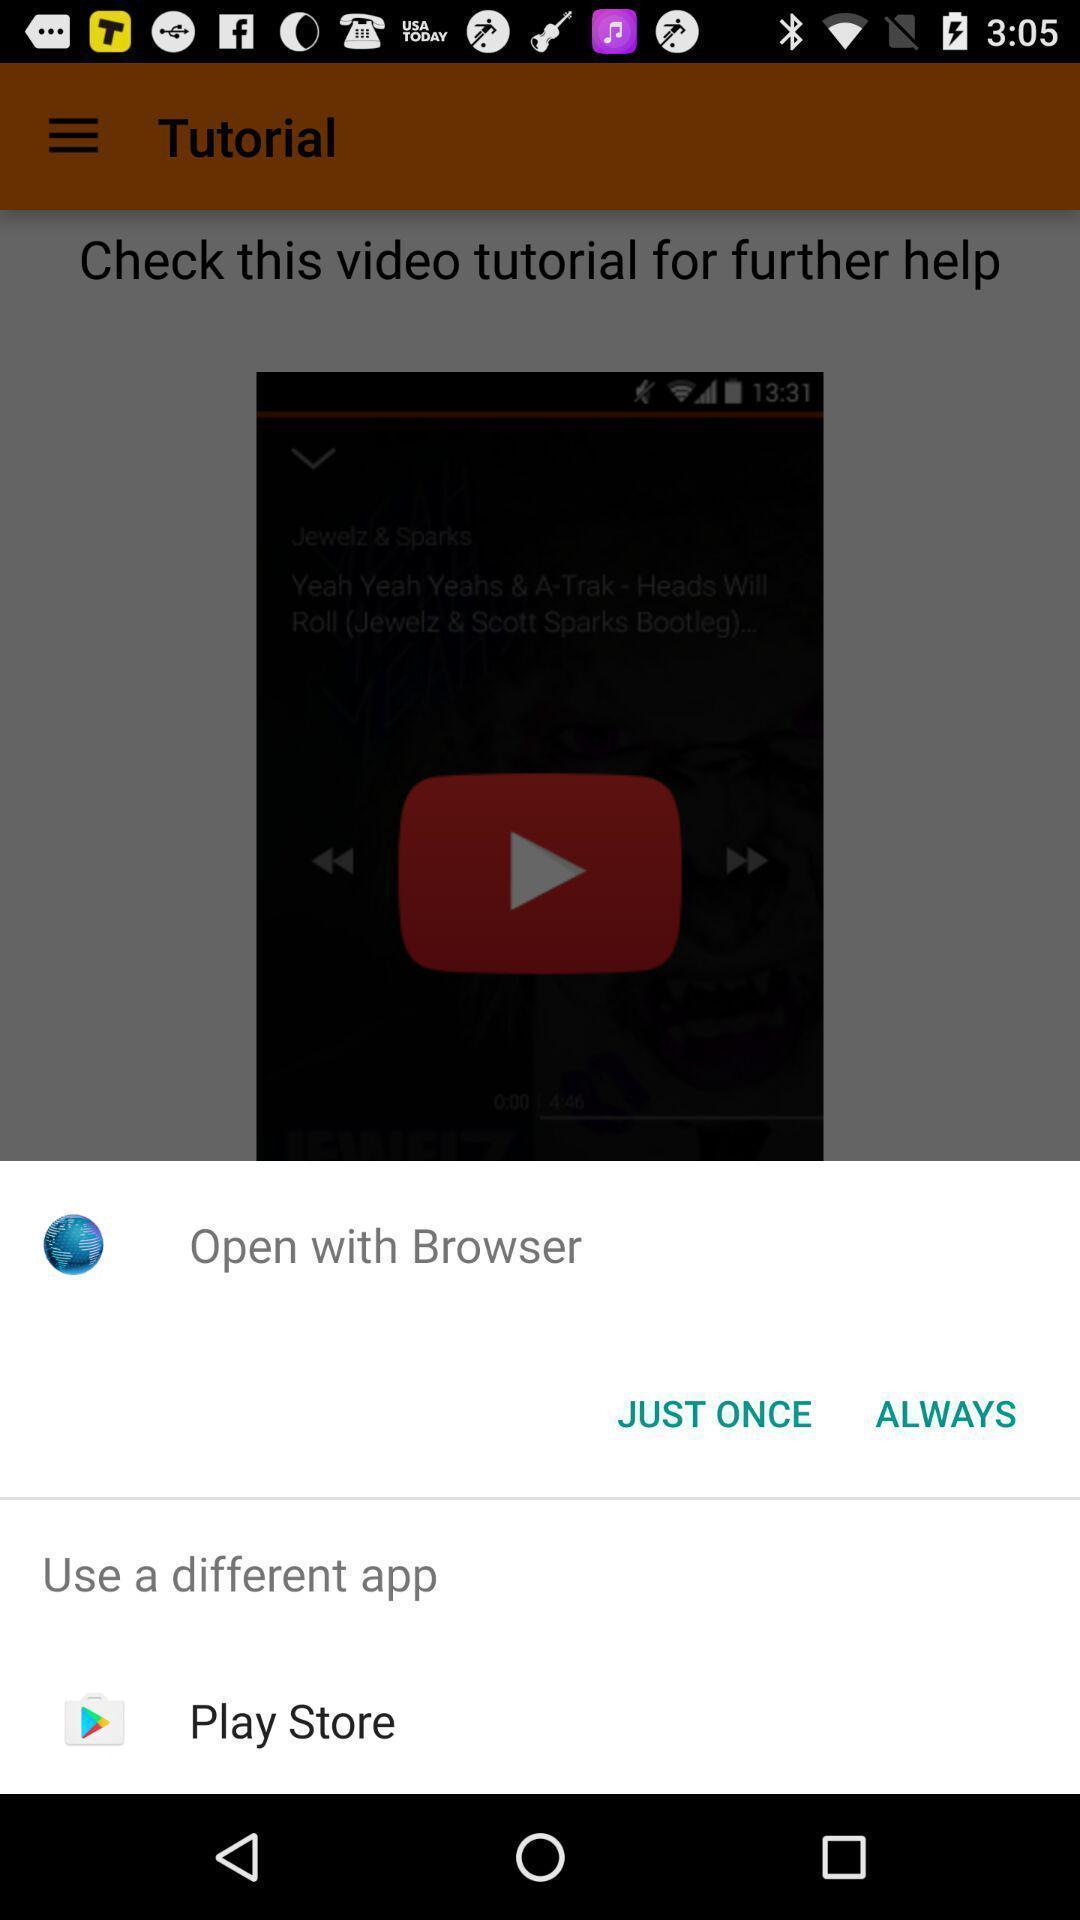What details can you identify in this image? Pop-up showing multiple options to open. 